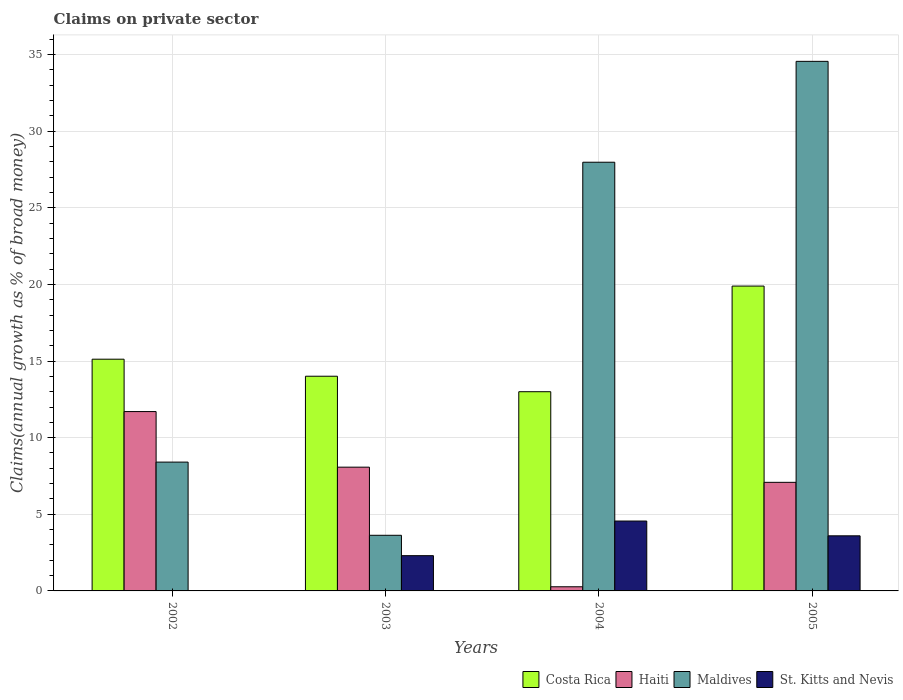How many groups of bars are there?
Offer a very short reply. 4. How many bars are there on the 4th tick from the left?
Provide a short and direct response. 4. How many bars are there on the 2nd tick from the right?
Make the answer very short. 4. What is the label of the 2nd group of bars from the left?
Your answer should be compact. 2003. In how many cases, is the number of bars for a given year not equal to the number of legend labels?
Offer a terse response. 1. What is the percentage of broad money claimed on private sector in Maldives in 2002?
Your response must be concise. 8.41. Across all years, what is the maximum percentage of broad money claimed on private sector in Costa Rica?
Your response must be concise. 19.89. In which year was the percentage of broad money claimed on private sector in Maldives maximum?
Make the answer very short. 2005. What is the total percentage of broad money claimed on private sector in Costa Rica in the graph?
Make the answer very short. 62.02. What is the difference between the percentage of broad money claimed on private sector in Haiti in 2002 and that in 2003?
Provide a succinct answer. 3.63. What is the difference between the percentage of broad money claimed on private sector in St. Kitts and Nevis in 2002 and the percentage of broad money claimed on private sector in Haiti in 2004?
Provide a short and direct response. -0.27. What is the average percentage of broad money claimed on private sector in Maldives per year?
Your response must be concise. 18.64. In the year 2002, what is the difference between the percentage of broad money claimed on private sector in Haiti and percentage of broad money claimed on private sector in Costa Rica?
Provide a succinct answer. -3.42. What is the ratio of the percentage of broad money claimed on private sector in Costa Rica in 2002 to that in 2005?
Offer a terse response. 0.76. Is the percentage of broad money claimed on private sector in Maldives in 2002 less than that in 2004?
Provide a short and direct response. Yes. What is the difference between the highest and the second highest percentage of broad money claimed on private sector in St. Kitts and Nevis?
Your answer should be compact. 0.96. What is the difference between the highest and the lowest percentage of broad money claimed on private sector in Maldives?
Offer a very short reply. 30.92. Is it the case that in every year, the sum of the percentage of broad money claimed on private sector in Maldives and percentage of broad money claimed on private sector in St. Kitts and Nevis is greater than the sum of percentage of broad money claimed on private sector in Haiti and percentage of broad money claimed on private sector in Costa Rica?
Provide a succinct answer. No. How many bars are there?
Offer a very short reply. 15. What is the difference between two consecutive major ticks on the Y-axis?
Provide a succinct answer. 5. Does the graph contain any zero values?
Provide a short and direct response. Yes. How many legend labels are there?
Offer a very short reply. 4. What is the title of the graph?
Offer a very short reply. Claims on private sector. What is the label or title of the X-axis?
Ensure brevity in your answer.  Years. What is the label or title of the Y-axis?
Provide a succinct answer. Claims(annual growth as % of broad money). What is the Claims(annual growth as % of broad money) of Costa Rica in 2002?
Provide a short and direct response. 15.12. What is the Claims(annual growth as % of broad money) in Haiti in 2002?
Provide a succinct answer. 11.7. What is the Claims(annual growth as % of broad money) of Maldives in 2002?
Provide a short and direct response. 8.41. What is the Claims(annual growth as % of broad money) in St. Kitts and Nevis in 2002?
Your answer should be compact. 0. What is the Claims(annual growth as % of broad money) of Costa Rica in 2003?
Give a very brief answer. 14.01. What is the Claims(annual growth as % of broad money) of Haiti in 2003?
Offer a very short reply. 8.08. What is the Claims(annual growth as % of broad money) of Maldives in 2003?
Provide a short and direct response. 3.63. What is the Claims(annual growth as % of broad money) in St. Kitts and Nevis in 2003?
Make the answer very short. 2.3. What is the Claims(annual growth as % of broad money) of Costa Rica in 2004?
Offer a very short reply. 13. What is the Claims(annual growth as % of broad money) in Haiti in 2004?
Keep it short and to the point. 0.27. What is the Claims(annual growth as % of broad money) in Maldives in 2004?
Your response must be concise. 27.97. What is the Claims(annual growth as % of broad money) in St. Kitts and Nevis in 2004?
Offer a very short reply. 4.56. What is the Claims(annual growth as % of broad money) of Costa Rica in 2005?
Your response must be concise. 19.89. What is the Claims(annual growth as % of broad money) of Haiti in 2005?
Provide a succinct answer. 7.09. What is the Claims(annual growth as % of broad money) in Maldives in 2005?
Provide a succinct answer. 34.55. What is the Claims(annual growth as % of broad money) in St. Kitts and Nevis in 2005?
Ensure brevity in your answer.  3.6. Across all years, what is the maximum Claims(annual growth as % of broad money) of Costa Rica?
Give a very brief answer. 19.89. Across all years, what is the maximum Claims(annual growth as % of broad money) of Haiti?
Provide a short and direct response. 11.7. Across all years, what is the maximum Claims(annual growth as % of broad money) in Maldives?
Make the answer very short. 34.55. Across all years, what is the maximum Claims(annual growth as % of broad money) of St. Kitts and Nevis?
Your response must be concise. 4.56. Across all years, what is the minimum Claims(annual growth as % of broad money) in Costa Rica?
Keep it short and to the point. 13. Across all years, what is the minimum Claims(annual growth as % of broad money) of Haiti?
Give a very brief answer. 0.27. Across all years, what is the minimum Claims(annual growth as % of broad money) in Maldives?
Your response must be concise. 3.63. What is the total Claims(annual growth as % of broad money) of Costa Rica in the graph?
Ensure brevity in your answer.  62.02. What is the total Claims(annual growth as % of broad money) of Haiti in the graph?
Your answer should be compact. 27.13. What is the total Claims(annual growth as % of broad money) of Maldives in the graph?
Provide a short and direct response. 74.56. What is the total Claims(annual growth as % of broad money) of St. Kitts and Nevis in the graph?
Offer a terse response. 10.45. What is the difference between the Claims(annual growth as % of broad money) of Costa Rica in 2002 and that in 2003?
Provide a short and direct response. 1.11. What is the difference between the Claims(annual growth as % of broad money) in Haiti in 2002 and that in 2003?
Provide a succinct answer. 3.63. What is the difference between the Claims(annual growth as % of broad money) of Maldives in 2002 and that in 2003?
Your response must be concise. 4.78. What is the difference between the Claims(annual growth as % of broad money) of Costa Rica in 2002 and that in 2004?
Your answer should be very brief. 2.12. What is the difference between the Claims(annual growth as % of broad money) in Haiti in 2002 and that in 2004?
Offer a very short reply. 11.43. What is the difference between the Claims(annual growth as % of broad money) of Maldives in 2002 and that in 2004?
Make the answer very short. -19.57. What is the difference between the Claims(annual growth as % of broad money) of Costa Rica in 2002 and that in 2005?
Provide a succinct answer. -4.77. What is the difference between the Claims(annual growth as % of broad money) of Haiti in 2002 and that in 2005?
Make the answer very short. 4.62. What is the difference between the Claims(annual growth as % of broad money) of Maldives in 2002 and that in 2005?
Provide a short and direct response. -26.15. What is the difference between the Claims(annual growth as % of broad money) of Haiti in 2003 and that in 2004?
Your answer should be compact. 7.8. What is the difference between the Claims(annual growth as % of broad money) in Maldives in 2003 and that in 2004?
Give a very brief answer. -24.34. What is the difference between the Claims(annual growth as % of broad money) of St. Kitts and Nevis in 2003 and that in 2004?
Ensure brevity in your answer.  -2.26. What is the difference between the Claims(annual growth as % of broad money) of Costa Rica in 2003 and that in 2005?
Ensure brevity in your answer.  -5.88. What is the difference between the Claims(annual growth as % of broad money) of Haiti in 2003 and that in 2005?
Provide a succinct answer. 0.99. What is the difference between the Claims(annual growth as % of broad money) of Maldives in 2003 and that in 2005?
Keep it short and to the point. -30.92. What is the difference between the Claims(annual growth as % of broad money) of St. Kitts and Nevis in 2003 and that in 2005?
Provide a short and direct response. -1.3. What is the difference between the Claims(annual growth as % of broad money) in Costa Rica in 2004 and that in 2005?
Your answer should be compact. -6.89. What is the difference between the Claims(annual growth as % of broad money) of Haiti in 2004 and that in 2005?
Provide a short and direct response. -6.81. What is the difference between the Claims(annual growth as % of broad money) of Maldives in 2004 and that in 2005?
Keep it short and to the point. -6.58. What is the difference between the Claims(annual growth as % of broad money) of St. Kitts and Nevis in 2004 and that in 2005?
Offer a very short reply. 0.96. What is the difference between the Claims(annual growth as % of broad money) in Costa Rica in 2002 and the Claims(annual growth as % of broad money) in Haiti in 2003?
Your answer should be compact. 7.05. What is the difference between the Claims(annual growth as % of broad money) in Costa Rica in 2002 and the Claims(annual growth as % of broad money) in Maldives in 2003?
Your answer should be very brief. 11.49. What is the difference between the Claims(annual growth as % of broad money) of Costa Rica in 2002 and the Claims(annual growth as % of broad money) of St. Kitts and Nevis in 2003?
Make the answer very short. 12.82. What is the difference between the Claims(annual growth as % of broad money) in Haiti in 2002 and the Claims(annual growth as % of broad money) in Maldives in 2003?
Provide a short and direct response. 8.07. What is the difference between the Claims(annual growth as % of broad money) of Haiti in 2002 and the Claims(annual growth as % of broad money) of St. Kitts and Nevis in 2003?
Provide a short and direct response. 9.4. What is the difference between the Claims(annual growth as % of broad money) in Maldives in 2002 and the Claims(annual growth as % of broad money) in St. Kitts and Nevis in 2003?
Your answer should be compact. 6.11. What is the difference between the Claims(annual growth as % of broad money) in Costa Rica in 2002 and the Claims(annual growth as % of broad money) in Haiti in 2004?
Give a very brief answer. 14.85. What is the difference between the Claims(annual growth as % of broad money) of Costa Rica in 2002 and the Claims(annual growth as % of broad money) of Maldives in 2004?
Offer a terse response. -12.85. What is the difference between the Claims(annual growth as % of broad money) in Costa Rica in 2002 and the Claims(annual growth as % of broad money) in St. Kitts and Nevis in 2004?
Ensure brevity in your answer.  10.56. What is the difference between the Claims(annual growth as % of broad money) in Haiti in 2002 and the Claims(annual growth as % of broad money) in Maldives in 2004?
Offer a terse response. -16.27. What is the difference between the Claims(annual growth as % of broad money) in Haiti in 2002 and the Claims(annual growth as % of broad money) in St. Kitts and Nevis in 2004?
Your answer should be very brief. 7.14. What is the difference between the Claims(annual growth as % of broad money) in Maldives in 2002 and the Claims(annual growth as % of broad money) in St. Kitts and Nevis in 2004?
Give a very brief answer. 3.85. What is the difference between the Claims(annual growth as % of broad money) in Costa Rica in 2002 and the Claims(annual growth as % of broad money) in Haiti in 2005?
Offer a terse response. 8.03. What is the difference between the Claims(annual growth as % of broad money) in Costa Rica in 2002 and the Claims(annual growth as % of broad money) in Maldives in 2005?
Offer a terse response. -19.43. What is the difference between the Claims(annual growth as % of broad money) of Costa Rica in 2002 and the Claims(annual growth as % of broad money) of St. Kitts and Nevis in 2005?
Your answer should be compact. 11.53. What is the difference between the Claims(annual growth as % of broad money) in Haiti in 2002 and the Claims(annual growth as % of broad money) in Maldives in 2005?
Your answer should be very brief. -22.85. What is the difference between the Claims(annual growth as % of broad money) in Haiti in 2002 and the Claims(annual growth as % of broad money) in St. Kitts and Nevis in 2005?
Offer a terse response. 8.11. What is the difference between the Claims(annual growth as % of broad money) in Maldives in 2002 and the Claims(annual growth as % of broad money) in St. Kitts and Nevis in 2005?
Offer a very short reply. 4.81. What is the difference between the Claims(annual growth as % of broad money) in Costa Rica in 2003 and the Claims(annual growth as % of broad money) in Haiti in 2004?
Provide a short and direct response. 13.74. What is the difference between the Claims(annual growth as % of broad money) in Costa Rica in 2003 and the Claims(annual growth as % of broad money) in Maldives in 2004?
Your answer should be very brief. -13.96. What is the difference between the Claims(annual growth as % of broad money) of Costa Rica in 2003 and the Claims(annual growth as % of broad money) of St. Kitts and Nevis in 2004?
Provide a short and direct response. 9.45. What is the difference between the Claims(annual growth as % of broad money) in Haiti in 2003 and the Claims(annual growth as % of broad money) in Maldives in 2004?
Give a very brief answer. -19.9. What is the difference between the Claims(annual growth as % of broad money) of Haiti in 2003 and the Claims(annual growth as % of broad money) of St. Kitts and Nevis in 2004?
Provide a short and direct response. 3.52. What is the difference between the Claims(annual growth as % of broad money) of Maldives in 2003 and the Claims(annual growth as % of broad money) of St. Kitts and Nevis in 2004?
Give a very brief answer. -0.93. What is the difference between the Claims(annual growth as % of broad money) in Costa Rica in 2003 and the Claims(annual growth as % of broad money) in Haiti in 2005?
Your response must be concise. 6.92. What is the difference between the Claims(annual growth as % of broad money) of Costa Rica in 2003 and the Claims(annual growth as % of broad money) of Maldives in 2005?
Your answer should be very brief. -20.55. What is the difference between the Claims(annual growth as % of broad money) in Costa Rica in 2003 and the Claims(annual growth as % of broad money) in St. Kitts and Nevis in 2005?
Provide a succinct answer. 10.41. What is the difference between the Claims(annual growth as % of broad money) of Haiti in 2003 and the Claims(annual growth as % of broad money) of Maldives in 2005?
Provide a short and direct response. -26.48. What is the difference between the Claims(annual growth as % of broad money) in Haiti in 2003 and the Claims(annual growth as % of broad money) in St. Kitts and Nevis in 2005?
Offer a terse response. 4.48. What is the difference between the Claims(annual growth as % of broad money) of Maldives in 2003 and the Claims(annual growth as % of broad money) of St. Kitts and Nevis in 2005?
Give a very brief answer. 0.04. What is the difference between the Claims(annual growth as % of broad money) of Costa Rica in 2004 and the Claims(annual growth as % of broad money) of Haiti in 2005?
Your answer should be very brief. 5.91. What is the difference between the Claims(annual growth as % of broad money) of Costa Rica in 2004 and the Claims(annual growth as % of broad money) of Maldives in 2005?
Ensure brevity in your answer.  -21.56. What is the difference between the Claims(annual growth as % of broad money) in Costa Rica in 2004 and the Claims(annual growth as % of broad money) in St. Kitts and Nevis in 2005?
Your answer should be compact. 9.4. What is the difference between the Claims(annual growth as % of broad money) in Haiti in 2004 and the Claims(annual growth as % of broad money) in Maldives in 2005?
Make the answer very short. -34.28. What is the difference between the Claims(annual growth as % of broad money) of Haiti in 2004 and the Claims(annual growth as % of broad money) of St. Kitts and Nevis in 2005?
Keep it short and to the point. -3.32. What is the difference between the Claims(annual growth as % of broad money) in Maldives in 2004 and the Claims(annual growth as % of broad money) in St. Kitts and Nevis in 2005?
Give a very brief answer. 24.38. What is the average Claims(annual growth as % of broad money) of Costa Rica per year?
Provide a succinct answer. 15.5. What is the average Claims(annual growth as % of broad money) of Haiti per year?
Offer a terse response. 6.78. What is the average Claims(annual growth as % of broad money) of Maldives per year?
Provide a short and direct response. 18.64. What is the average Claims(annual growth as % of broad money) in St. Kitts and Nevis per year?
Your answer should be compact. 2.61. In the year 2002, what is the difference between the Claims(annual growth as % of broad money) of Costa Rica and Claims(annual growth as % of broad money) of Haiti?
Give a very brief answer. 3.42. In the year 2002, what is the difference between the Claims(annual growth as % of broad money) in Costa Rica and Claims(annual growth as % of broad money) in Maldives?
Offer a terse response. 6.71. In the year 2002, what is the difference between the Claims(annual growth as % of broad money) in Haiti and Claims(annual growth as % of broad money) in Maldives?
Offer a very short reply. 3.3. In the year 2003, what is the difference between the Claims(annual growth as % of broad money) of Costa Rica and Claims(annual growth as % of broad money) of Haiti?
Provide a short and direct response. 5.93. In the year 2003, what is the difference between the Claims(annual growth as % of broad money) in Costa Rica and Claims(annual growth as % of broad money) in Maldives?
Your response must be concise. 10.38. In the year 2003, what is the difference between the Claims(annual growth as % of broad money) in Costa Rica and Claims(annual growth as % of broad money) in St. Kitts and Nevis?
Offer a terse response. 11.71. In the year 2003, what is the difference between the Claims(annual growth as % of broad money) in Haiti and Claims(annual growth as % of broad money) in Maldives?
Offer a terse response. 4.44. In the year 2003, what is the difference between the Claims(annual growth as % of broad money) in Haiti and Claims(annual growth as % of broad money) in St. Kitts and Nevis?
Offer a very short reply. 5.78. In the year 2003, what is the difference between the Claims(annual growth as % of broad money) in Maldives and Claims(annual growth as % of broad money) in St. Kitts and Nevis?
Provide a short and direct response. 1.33. In the year 2004, what is the difference between the Claims(annual growth as % of broad money) of Costa Rica and Claims(annual growth as % of broad money) of Haiti?
Keep it short and to the point. 12.73. In the year 2004, what is the difference between the Claims(annual growth as % of broad money) of Costa Rica and Claims(annual growth as % of broad money) of Maldives?
Your response must be concise. -14.97. In the year 2004, what is the difference between the Claims(annual growth as % of broad money) of Costa Rica and Claims(annual growth as % of broad money) of St. Kitts and Nevis?
Make the answer very short. 8.44. In the year 2004, what is the difference between the Claims(annual growth as % of broad money) of Haiti and Claims(annual growth as % of broad money) of Maldives?
Keep it short and to the point. -27.7. In the year 2004, what is the difference between the Claims(annual growth as % of broad money) of Haiti and Claims(annual growth as % of broad money) of St. Kitts and Nevis?
Offer a terse response. -4.29. In the year 2004, what is the difference between the Claims(annual growth as % of broad money) in Maldives and Claims(annual growth as % of broad money) in St. Kitts and Nevis?
Offer a terse response. 23.41. In the year 2005, what is the difference between the Claims(annual growth as % of broad money) of Costa Rica and Claims(annual growth as % of broad money) of Haiti?
Keep it short and to the point. 12.81. In the year 2005, what is the difference between the Claims(annual growth as % of broad money) in Costa Rica and Claims(annual growth as % of broad money) in Maldives?
Ensure brevity in your answer.  -14.66. In the year 2005, what is the difference between the Claims(annual growth as % of broad money) of Costa Rica and Claims(annual growth as % of broad money) of St. Kitts and Nevis?
Ensure brevity in your answer.  16.3. In the year 2005, what is the difference between the Claims(annual growth as % of broad money) of Haiti and Claims(annual growth as % of broad money) of Maldives?
Provide a succinct answer. -27.47. In the year 2005, what is the difference between the Claims(annual growth as % of broad money) of Haiti and Claims(annual growth as % of broad money) of St. Kitts and Nevis?
Your response must be concise. 3.49. In the year 2005, what is the difference between the Claims(annual growth as % of broad money) in Maldives and Claims(annual growth as % of broad money) in St. Kitts and Nevis?
Keep it short and to the point. 30.96. What is the ratio of the Claims(annual growth as % of broad money) of Costa Rica in 2002 to that in 2003?
Ensure brevity in your answer.  1.08. What is the ratio of the Claims(annual growth as % of broad money) of Haiti in 2002 to that in 2003?
Make the answer very short. 1.45. What is the ratio of the Claims(annual growth as % of broad money) in Maldives in 2002 to that in 2003?
Keep it short and to the point. 2.32. What is the ratio of the Claims(annual growth as % of broad money) of Costa Rica in 2002 to that in 2004?
Make the answer very short. 1.16. What is the ratio of the Claims(annual growth as % of broad money) of Haiti in 2002 to that in 2004?
Keep it short and to the point. 43.18. What is the ratio of the Claims(annual growth as % of broad money) of Maldives in 2002 to that in 2004?
Give a very brief answer. 0.3. What is the ratio of the Claims(annual growth as % of broad money) of Costa Rica in 2002 to that in 2005?
Give a very brief answer. 0.76. What is the ratio of the Claims(annual growth as % of broad money) of Haiti in 2002 to that in 2005?
Offer a very short reply. 1.65. What is the ratio of the Claims(annual growth as % of broad money) in Maldives in 2002 to that in 2005?
Provide a succinct answer. 0.24. What is the ratio of the Claims(annual growth as % of broad money) in Costa Rica in 2003 to that in 2004?
Your answer should be compact. 1.08. What is the ratio of the Claims(annual growth as % of broad money) of Haiti in 2003 to that in 2004?
Provide a short and direct response. 29.8. What is the ratio of the Claims(annual growth as % of broad money) of Maldives in 2003 to that in 2004?
Offer a terse response. 0.13. What is the ratio of the Claims(annual growth as % of broad money) in St. Kitts and Nevis in 2003 to that in 2004?
Give a very brief answer. 0.5. What is the ratio of the Claims(annual growth as % of broad money) of Costa Rica in 2003 to that in 2005?
Give a very brief answer. 0.7. What is the ratio of the Claims(annual growth as % of broad money) in Haiti in 2003 to that in 2005?
Give a very brief answer. 1.14. What is the ratio of the Claims(annual growth as % of broad money) of Maldives in 2003 to that in 2005?
Ensure brevity in your answer.  0.11. What is the ratio of the Claims(annual growth as % of broad money) in St. Kitts and Nevis in 2003 to that in 2005?
Offer a very short reply. 0.64. What is the ratio of the Claims(annual growth as % of broad money) in Costa Rica in 2004 to that in 2005?
Ensure brevity in your answer.  0.65. What is the ratio of the Claims(annual growth as % of broad money) in Haiti in 2004 to that in 2005?
Offer a terse response. 0.04. What is the ratio of the Claims(annual growth as % of broad money) of Maldives in 2004 to that in 2005?
Your answer should be very brief. 0.81. What is the ratio of the Claims(annual growth as % of broad money) of St. Kitts and Nevis in 2004 to that in 2005?
Offer a very short reply. 1.27. What is the difference between the highest and the second highest Claims(annual growth as % of broad money) in Costa Rica?
Provide a short and direct response. 4.77. What is the difference between the highest and the second highest Claims(annual growth as % of broad money) of Haiti?
Make the answer very short. 3.63. What is the difference between the highest and the second highest Claims(annual growth as % of broad money) of Maldives?
Offer a very short reply. 6.58. What is the difference between the highest and the second highest Claims(annual growth as % of broad money) of St. Kitts and Nevis?
Provide a succinct answer. 0.96. What is the difference between the highest and the lowest Claims(annual growth as % of broad money) of Costa Rica?
Keep it short and to the point. 6.89. What is the difference between the highest and the lowest Claims(annual growth as % of broad money) in Haiti?
Provide a short and direct response. 11.43. What is the difference between the highest and the lowest Claims(annual growth as % of broad money) of Maldives?
Your answer should be very brief. 30.92. What is the difference between the highest and the lowest Claims(annual growth as % of broad money) in St. Kitts and Nevis?
Your response must be concise. 4.56. 